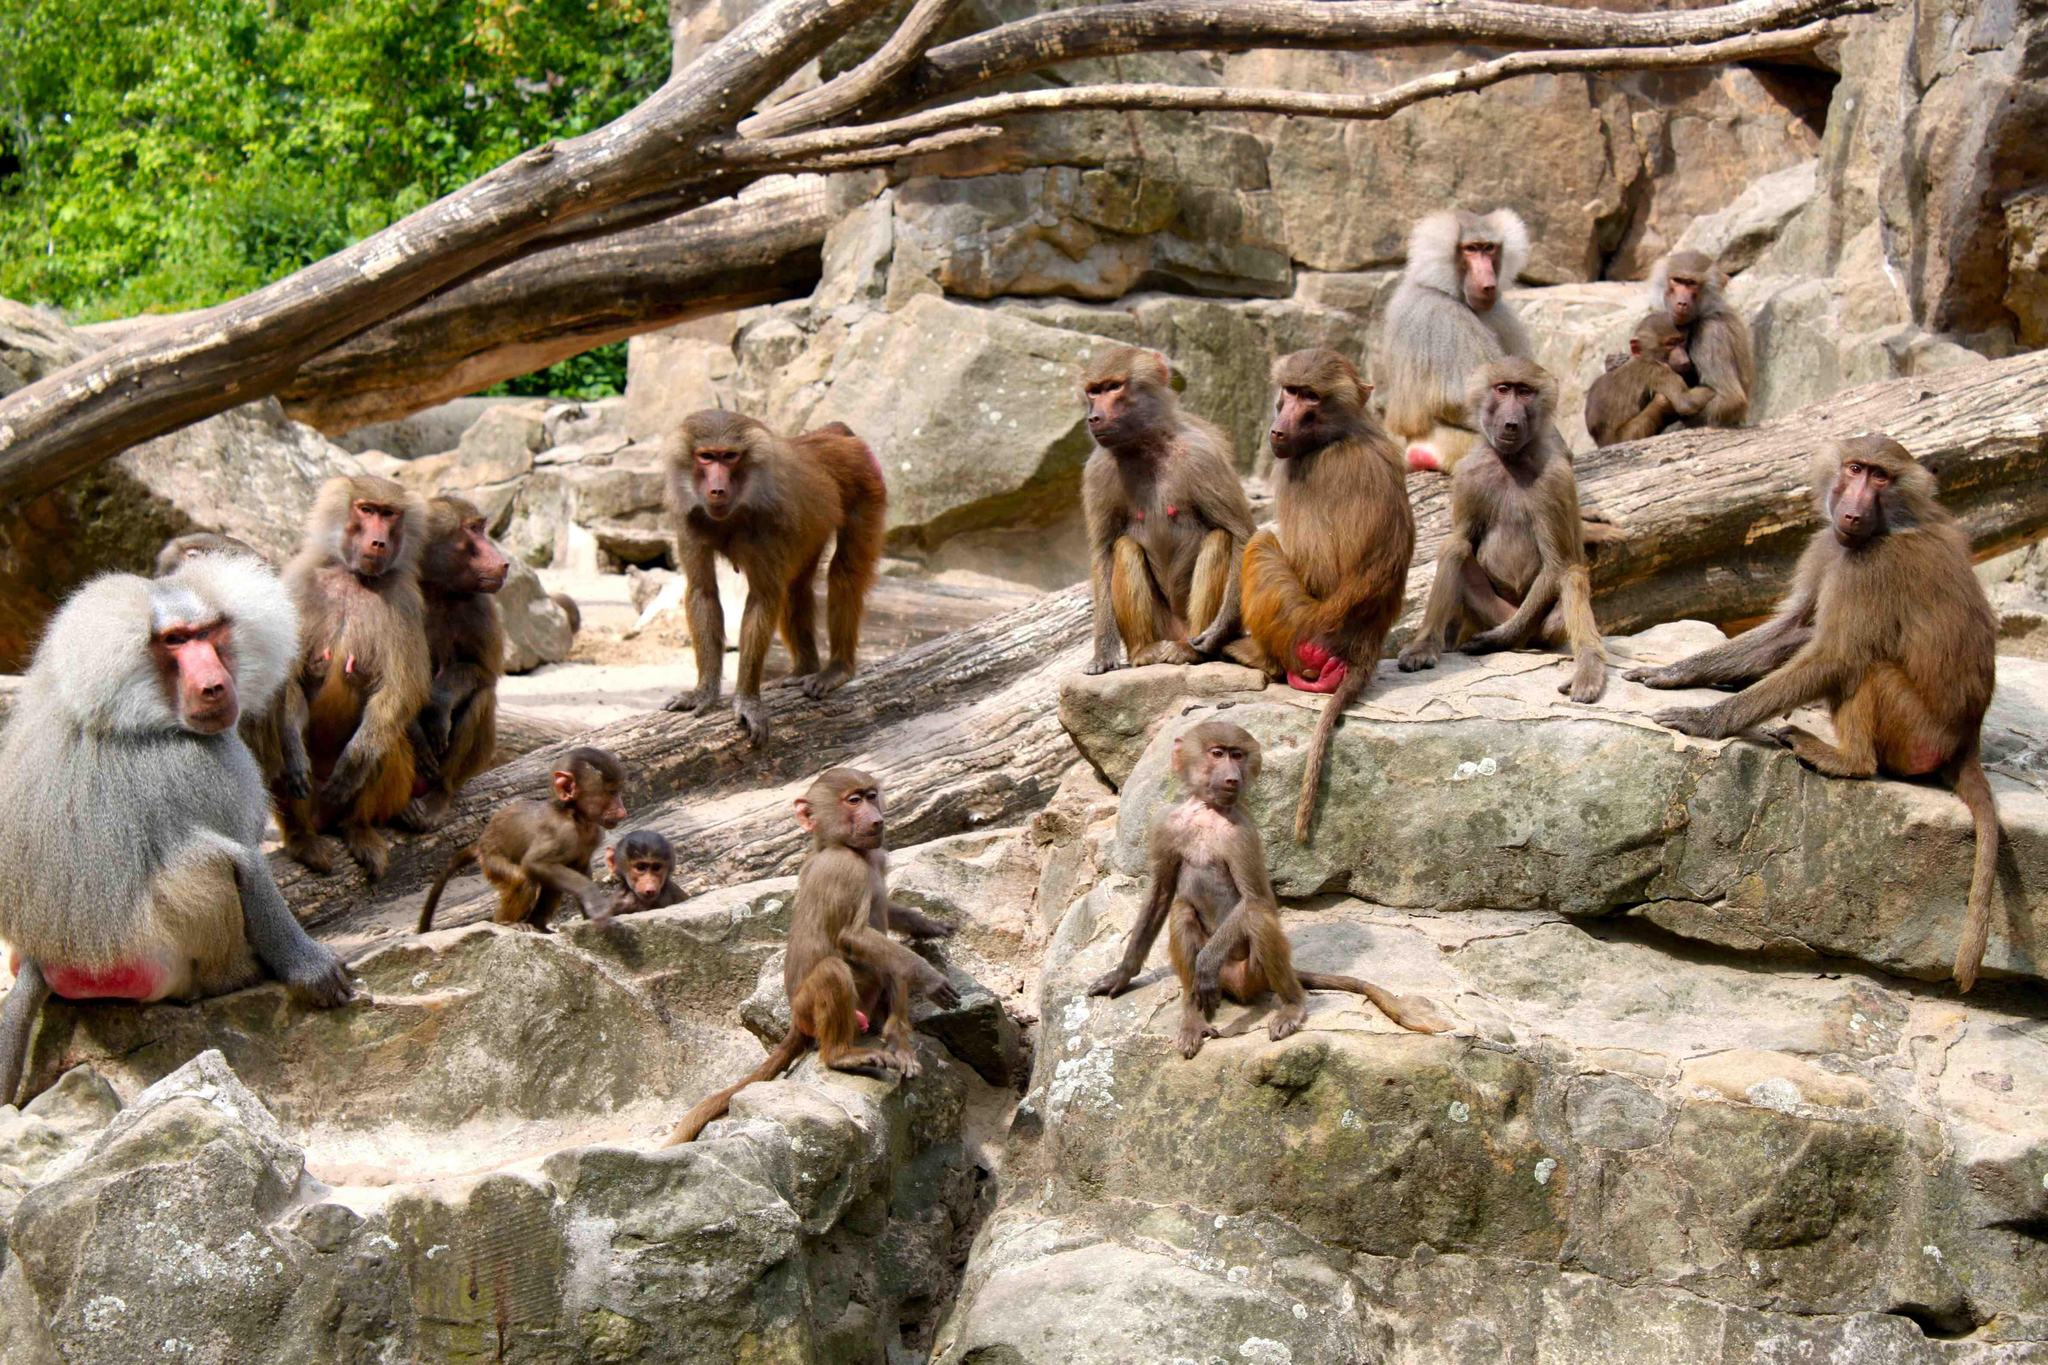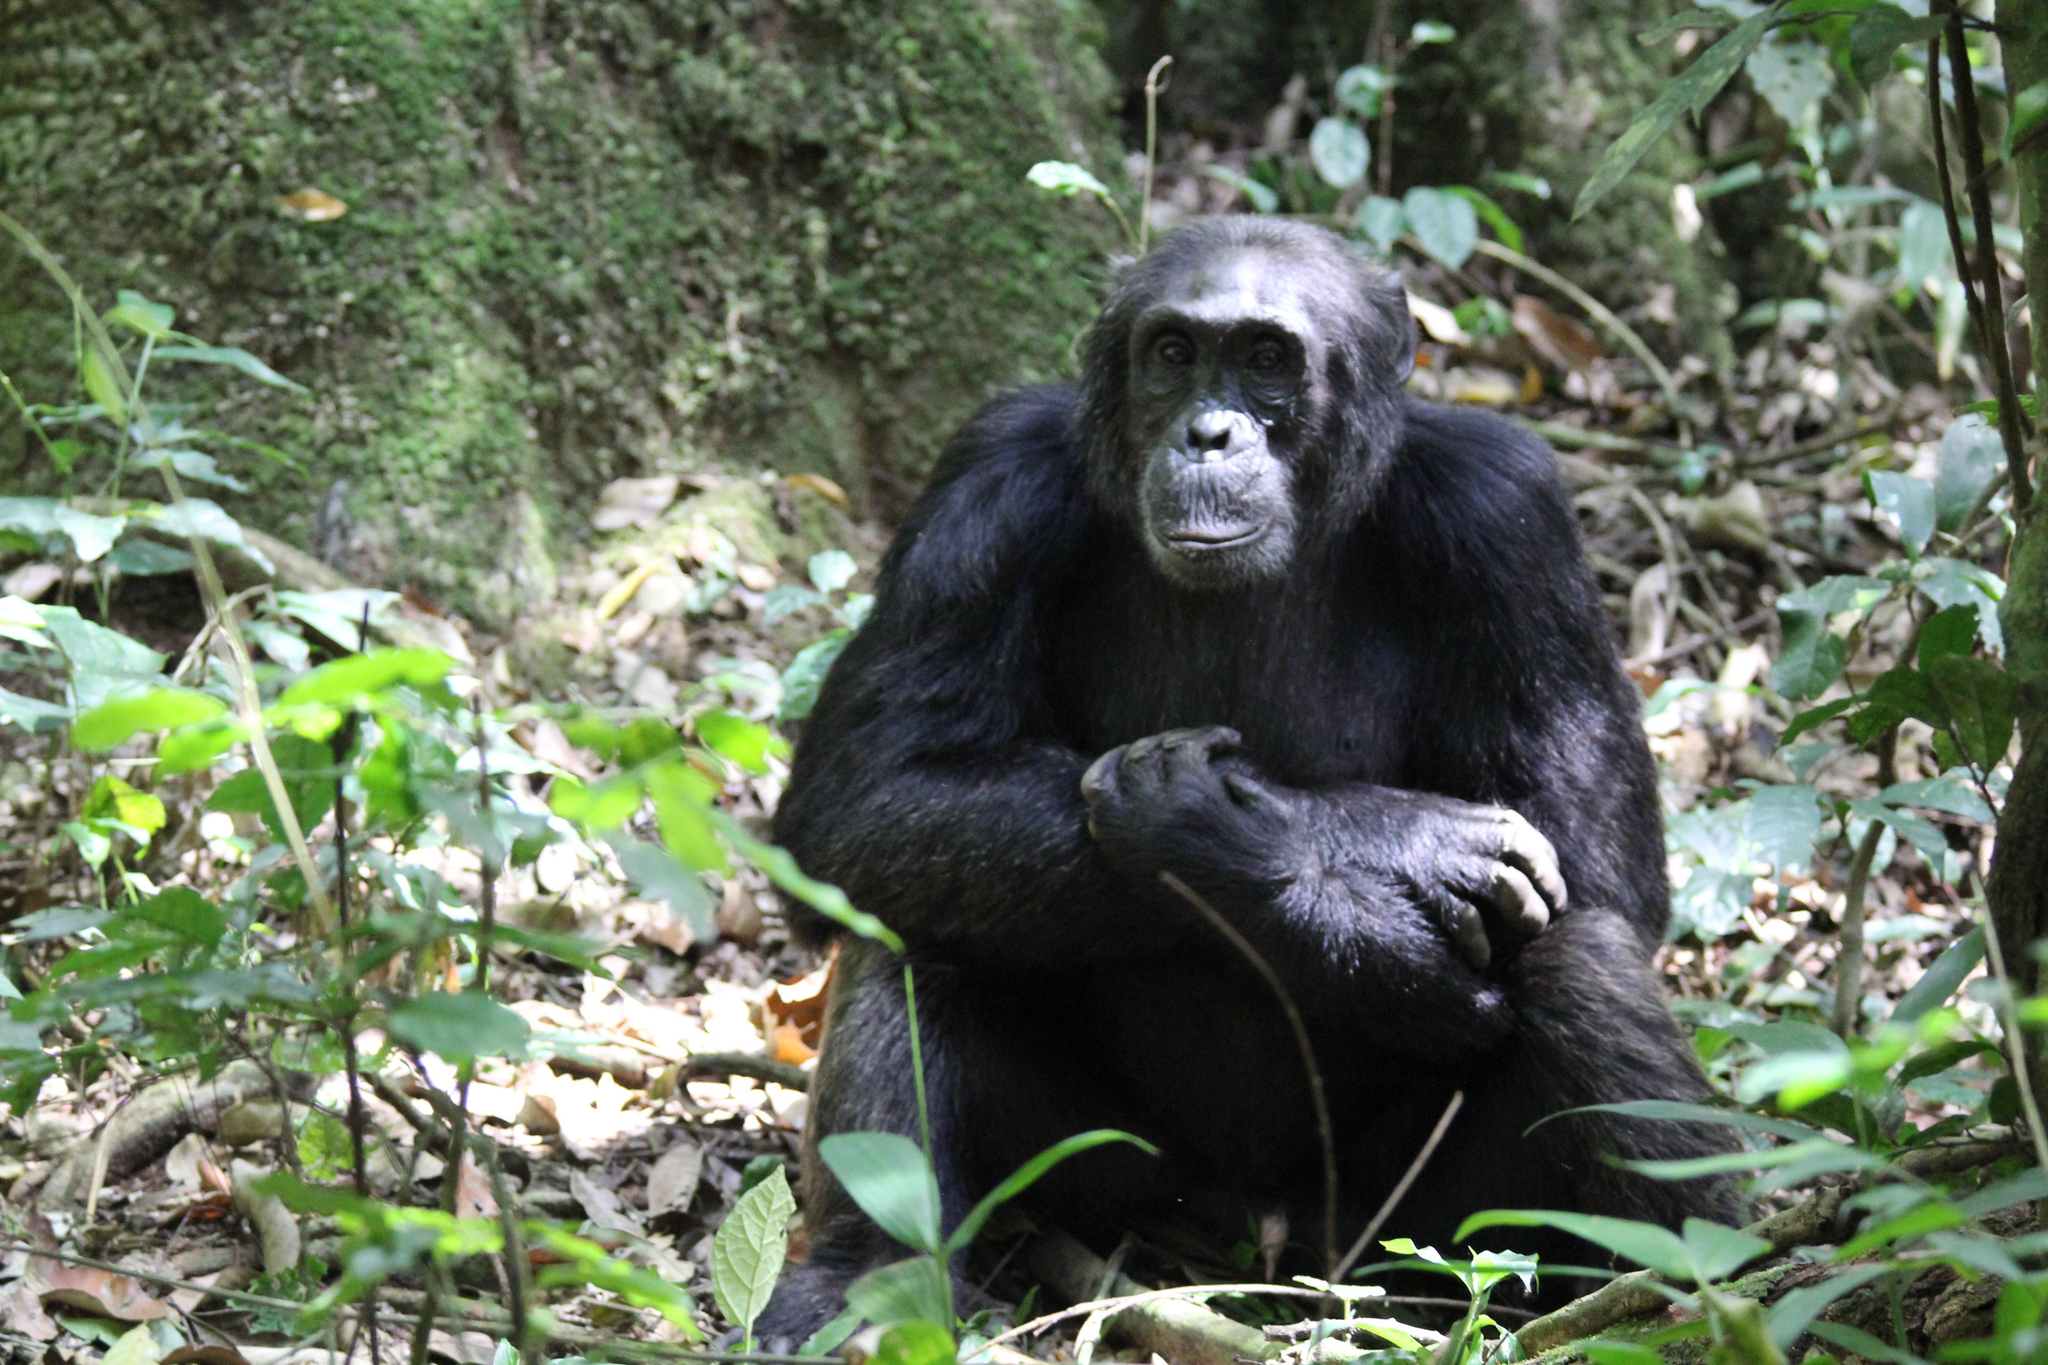The first image is the image on the left, the second image is the image on the right. For the images shown, is this caption "In total, the images depict at least four black-haired apes." true? Answer yes or no. No. 